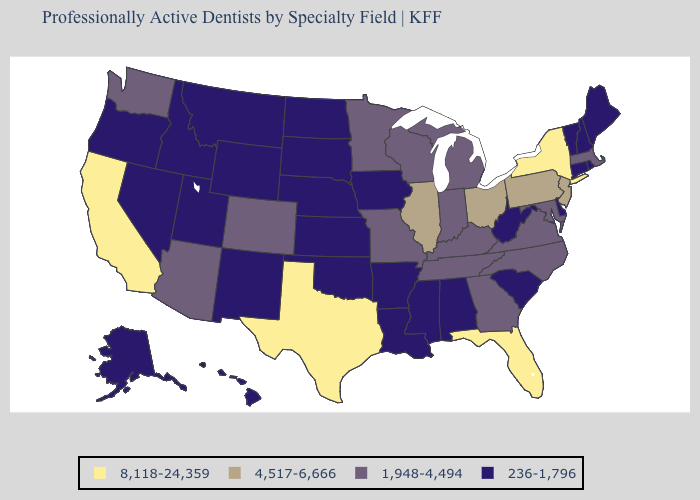What is the highest value in the Northeast ?
Keep it brief. 8,118-24,359. What is the lowest value in the South?
Short answer required. 236-1,796. Name the states that have a value in the range 1,948-4,494?
Keep it brief. Arizona, Colorado, Georgia, Indiana, Kentucky, Maryland, Massachusetts, Michigan, Minnesota, Missouri, North Carolina, Tennessee, Virginia, Washington, Wisconsin. Does the map have missing data?
Keep it brief. No. Does Wisconsin have a higher value than Rhode Island?
Be succinct. Yes. What is the value of Alaska?
Keep it brief. 236-1,796. What is the highest value in the USA?
Short answer required. 8,118-24,359. What is the value of Iowa?
Be succinct. 236-1,796. What is the value of Rhode Island?
Be succinct. 236-1,796. Which states have the lowest value in the USA?
Keep it brief. Alabama, Alaska, Arkansas, Connecticut, Delaware, Hawaii, Idaho, Iowa, Kansas, Louisiana, Maine, Mississippi, Montana, Nebraska, Nevada, New Hampshire, New Mexico, North Dakota, Oklahoma, Oregon, Rhode Island, South Carolina, South Dakota, Utah, Vermont, West Virginia, Wyoming. What is the value of Michigan?
Be succinct. 1,948-4,494. What is the value of Maryland?
Keep it brief. 1,948-4,494. Among the states that border Colorado , does New Mexico have the lowest value?
Keep it brief. Yes. Does Delaware have the highest value in the USA?
Concise answer only. No. What is the highest value in the USA?
Answer briefly. 8,118-24,359. 